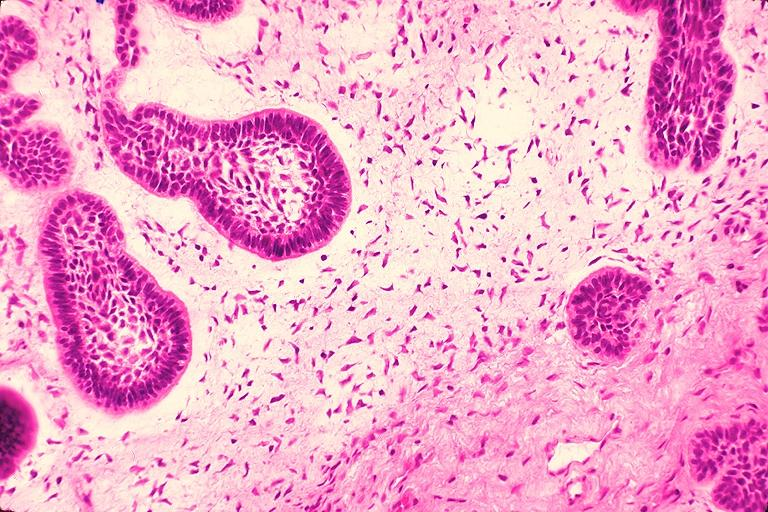does fibroma show ameloblastic fibroma?
Answer the question using a single word or phrase. No 